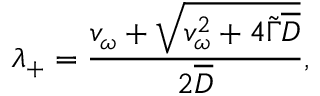<formula> <loc_0><loc_0><loc_500><loc_500>\lambda _ { + } = \frac { v _ { \omega } + \sqrt { v _ { \omega } ^ { 2 } + 4 \widetilde { \Gamma } \overline { D } } } { 2 \overline { D } } ,</formula> 